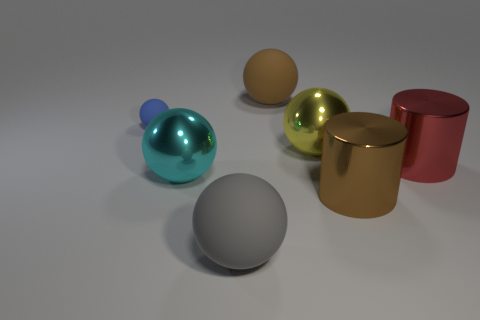Subtract all small blue balls. How many balls are left? 4 Subtract all yellow balls. How many balls are left? 4 Add 1 big brown things. How many objects exist? 8 Subtract all red balls. Subtract all cyan cylinders. How many balls are left? 5 Subtract all balls. How many objects are left? 2 Add 5 tiny red metallic balls. How many tiny red metallic balls exist? 5 Subtract 0 cyan cubes. How many objects are left? 7 Subtract all brown metal things. Subtract all brown matte balls. How many objects are left? 5 Add 2 red metallic cylinders. How many red metallic cylinders are left? 3 